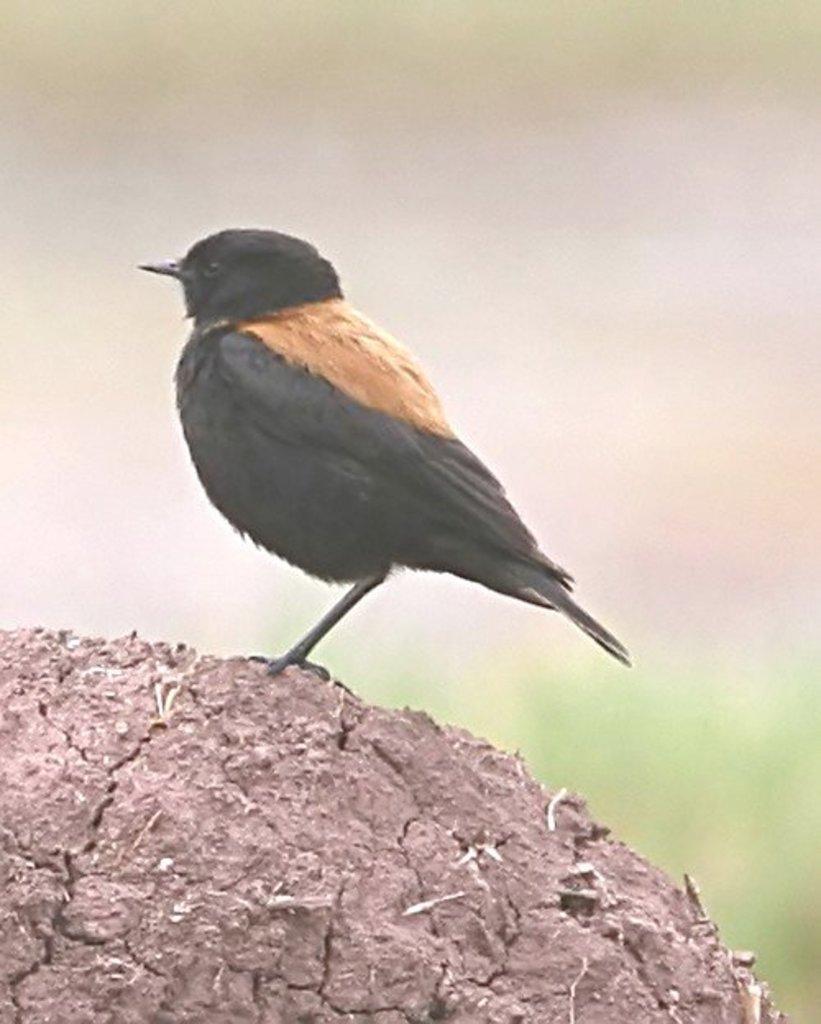How would you summarize this image in a sentence or two? In this picture there is a bird in the center of the image on a muddy texture. 